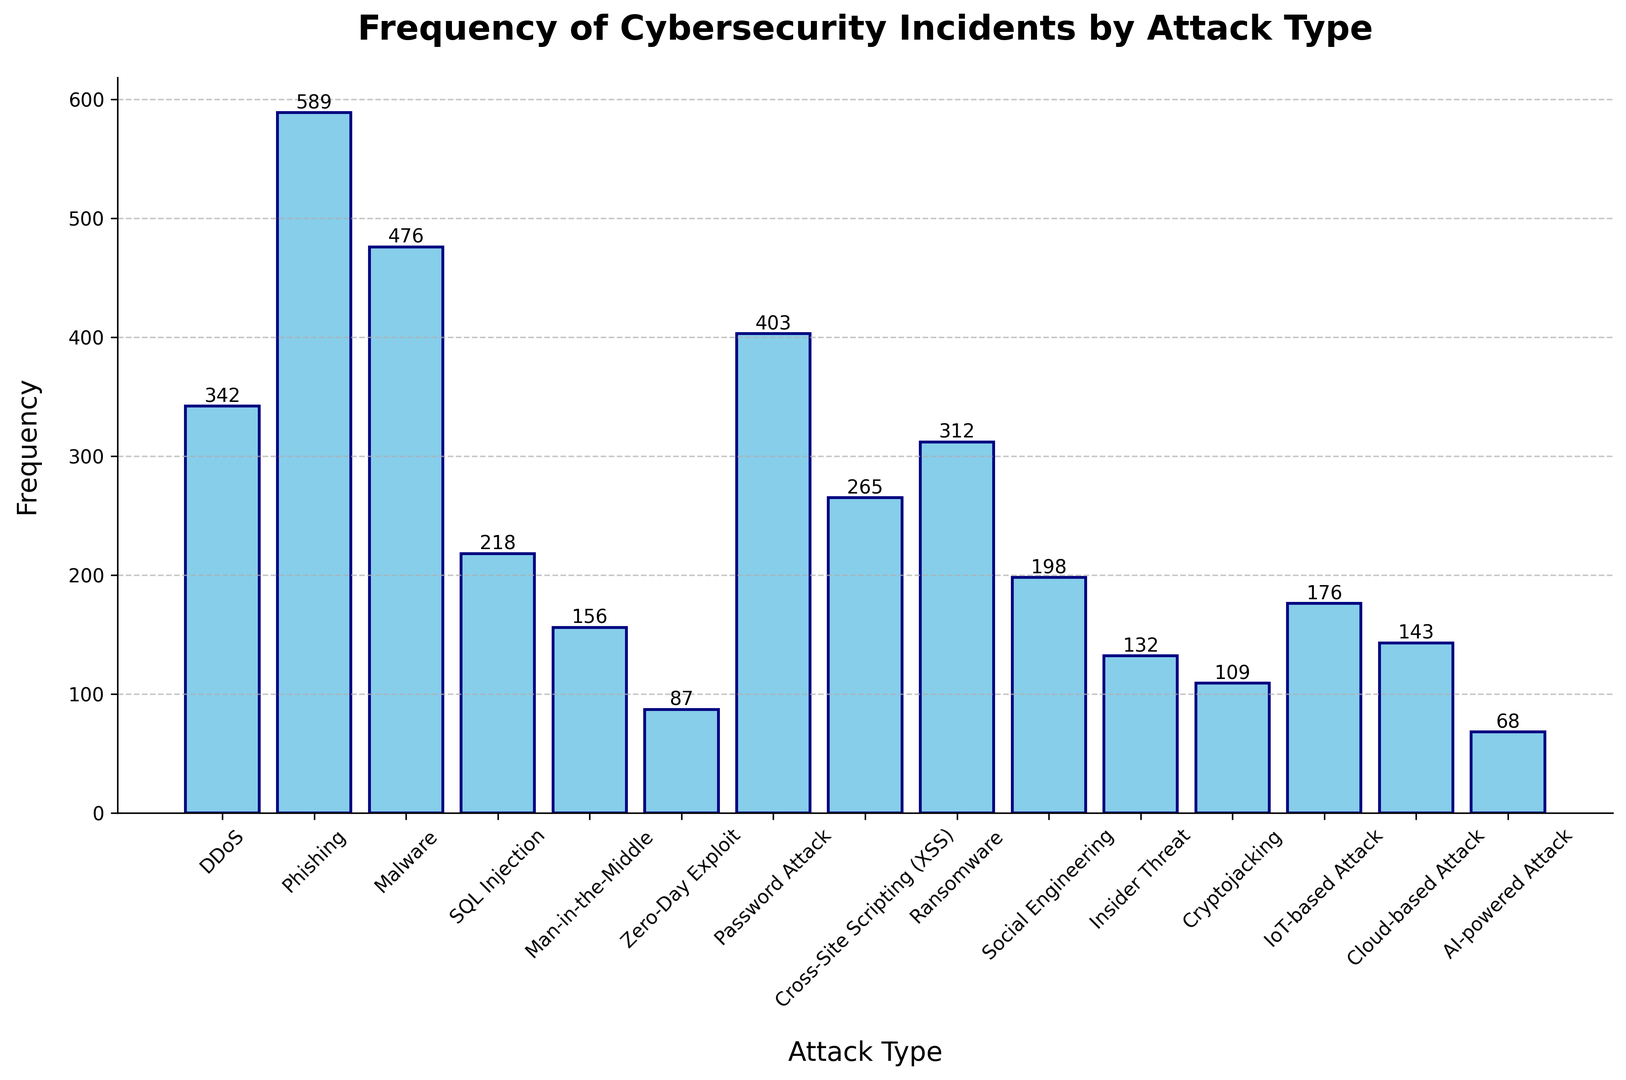What is the most frequent type of cybersecurity incident? The tallest bar in the histogram corresponds to the highest frequency. By looking at the figure, the bar for "Phishing" is the tallest, indicating it has the most occurrences.
Answer: Phishing Which type of attack has the least number of incidents? To find the least frequent attack, locate the shortest bar in the histogram. The shortest bar corresponds to "AI-powered Attack," meaning it has the fewest incidents.
Answer: AI-powered Attack How many more incidents does Phishing have compared to Ransomware? Locate the heights of the bars for "Phishing" and "Ransomware." The difference in their frequencies is calculated as 589 (Phishing) - 312 (Ransomware).
Answer: 277 What is the sum of incidents for DDoS, Malware, and Password Attack? Sum the frequencies of the bars for DDoS, Malware, and Password Attack. The calculation is 342 (DDoS) + 476 (Malware) + 403 (Password Attack).
Answer: 1221 How does the frequency of Cryptojacking compare to Insider Threat? Compare the heights of the bars for "Cryptojacking" and "Insider Threat." Cryptojacking has a frequency of 109 while Insider Threat has 132. Cryptojacking has fewer incidents.
Answer: Cryptojacking has fewer incidents What is the total number of cybersecurity incidents shown in the histogram? Add the frequencies of all attack types listed in the histogram. Sum these values: 342 + 589 + 476 + 218 + 156 + 87 + 403 + 265 + 312 + 198 + 132 + 109 + 176 + 143 + 68.
Answer: 3674 Which attack type has nearly the same frequency as Cloud-based Attack? Compare the height of the bar for "Cloud-based Attack" with others. Cloud-based Attack has 143 incidents, and Man-in-the-Middle Attack has a similar frequency with 156 incidents.
Answer: Man-in-the-Middle What is the average frequency of the incidents for Cross-Site Scripting (XSS), Social Engineering, and Insider Threat? Calculate the average by summing the frequencies and then dividing by the number of attack types. (265 (XSS) + 198 (Social Engineering) + 132 (Insider Threat)) / 3.
Answer: 198.33 How many incidents are there for the three least frequent attack types combined? Identify and sum the three shortest bars from the histogram: AI-powered Attack (68), Zero-Day Exploit (87), and Cryptojacking (109). The calculation is 68 + 87 + 109.
Answer: 264 Rank the following attack types from most to least frequent: Password Attack, Malware, and SQL Injection. Compare the heights of the bars for Password Attack, Malware, and SQL Injection. Their frequencies are 403 (Password Attack), 476 (Malware), and 218 (SQL Injection) respectively, so the order is Malware > Password Attack > SQL Injection.
Answer: Malware > Password Attack > SQL Injection 